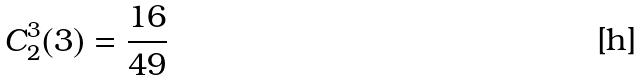<formula> <loc_0><loc_0><loc_500><loc_500>C _ { 2 } ^ { 3 } ( 3 ) = \frac { 1 6 } { 4 9 }</formula> 